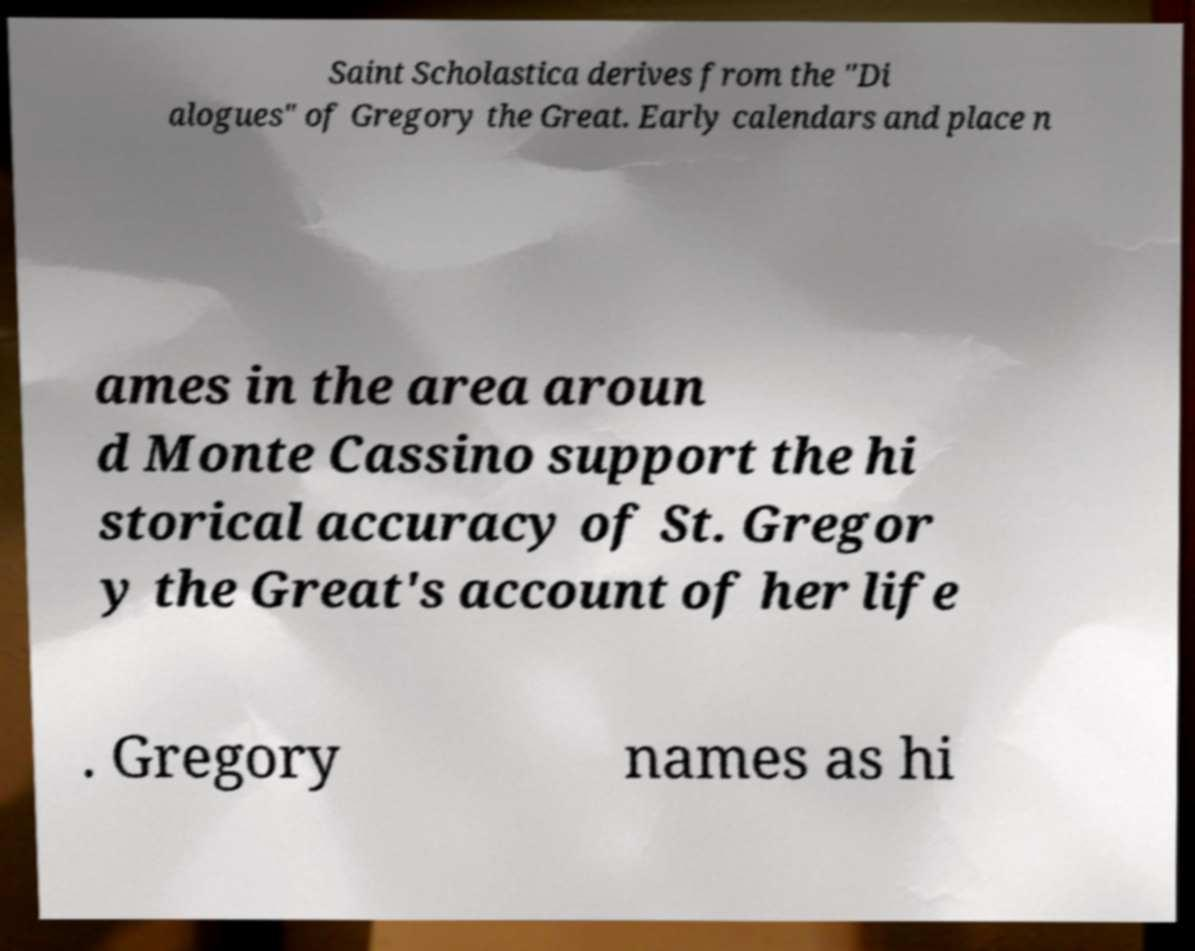Can you read and provide the text displayed in the image?This photo seems to have some interesting text. Can you extract and type it out for me? Saint Scholastica derives from the "Di alogues" of Gregory the Great. Early calendars and place n ames in the area aroun d Monte Cassino support the hi storical accuracy of St. Gregor y the Great's account of her life . Gregory names as hi 